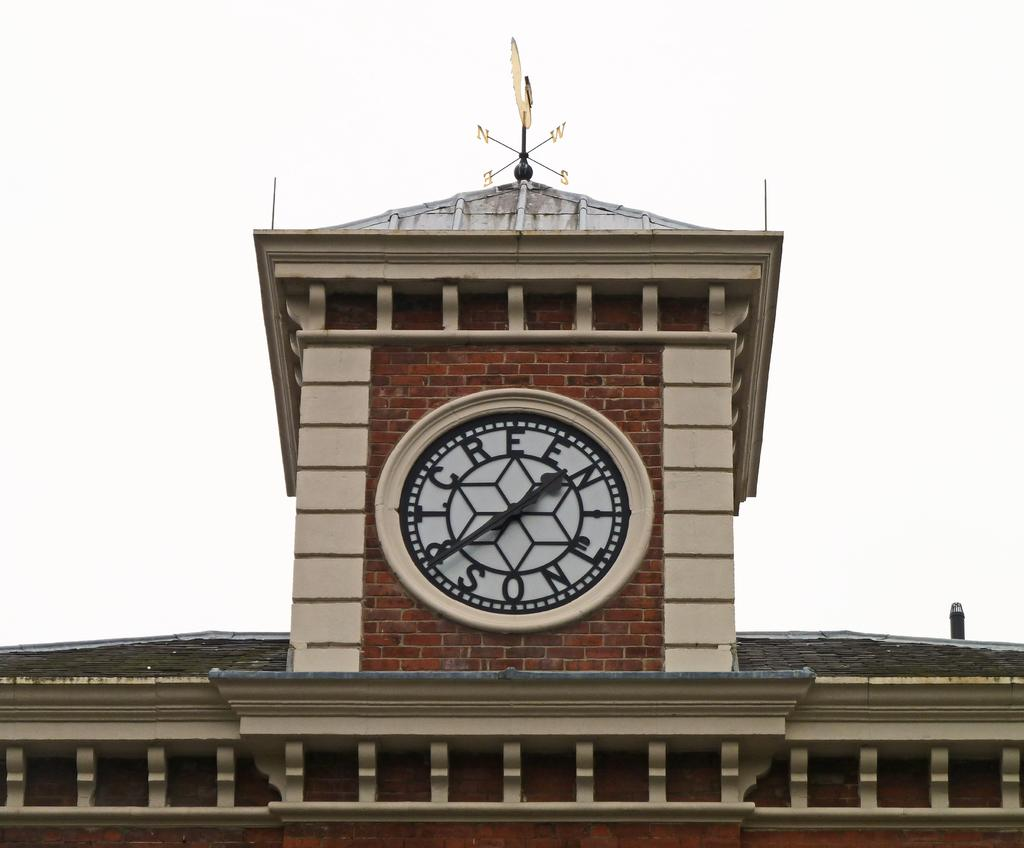What object can be seen on a wall in the image? There is a clock on a wall in the image. What structure has a navigation pole at the top in the image? There is a building in the image with a navigation pole at the top. What can be seen in the background of the image? The sky is visible in the background of the image. How many beads are hanging from the clock in the image? There are no beads hanging from the clock in the image; it is a clock on a wall. What type of comb is used to clean the navigation pole in the image? There is no comb present in the image, nor is there any indication that the navigation pole needs cleaning. 